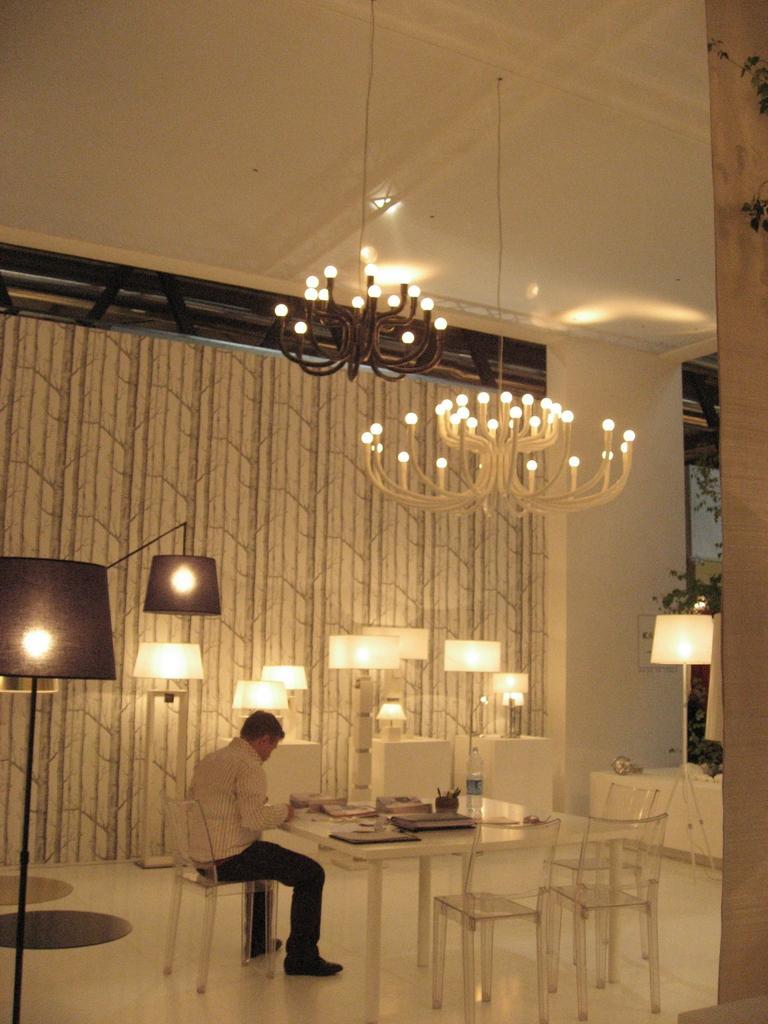Please provide a concise description of this image. this picture shows a man cheated on chair and we see few books and water bottle and pen stand on the table and we see couple of chairs and two chandelier lights on the roof and we see few lights on the side and we see a curtain to the window 